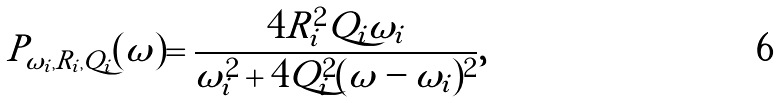<formula> <loc_0><loc_0><loc_500><loc_500>P _ { \omega _ { i } , R _ { i } , Q _ { i } } ( \omega ) = \frac { 4 R _ { i } ^ { 2 } Q _ { i } \omega _ { i } } { \omega _ { i } ^ { 2 } + 4 Q _ { i } ^ { 2 } ( \omega - \omega _ { i } ) ^ { 2 } } ,</formula> 